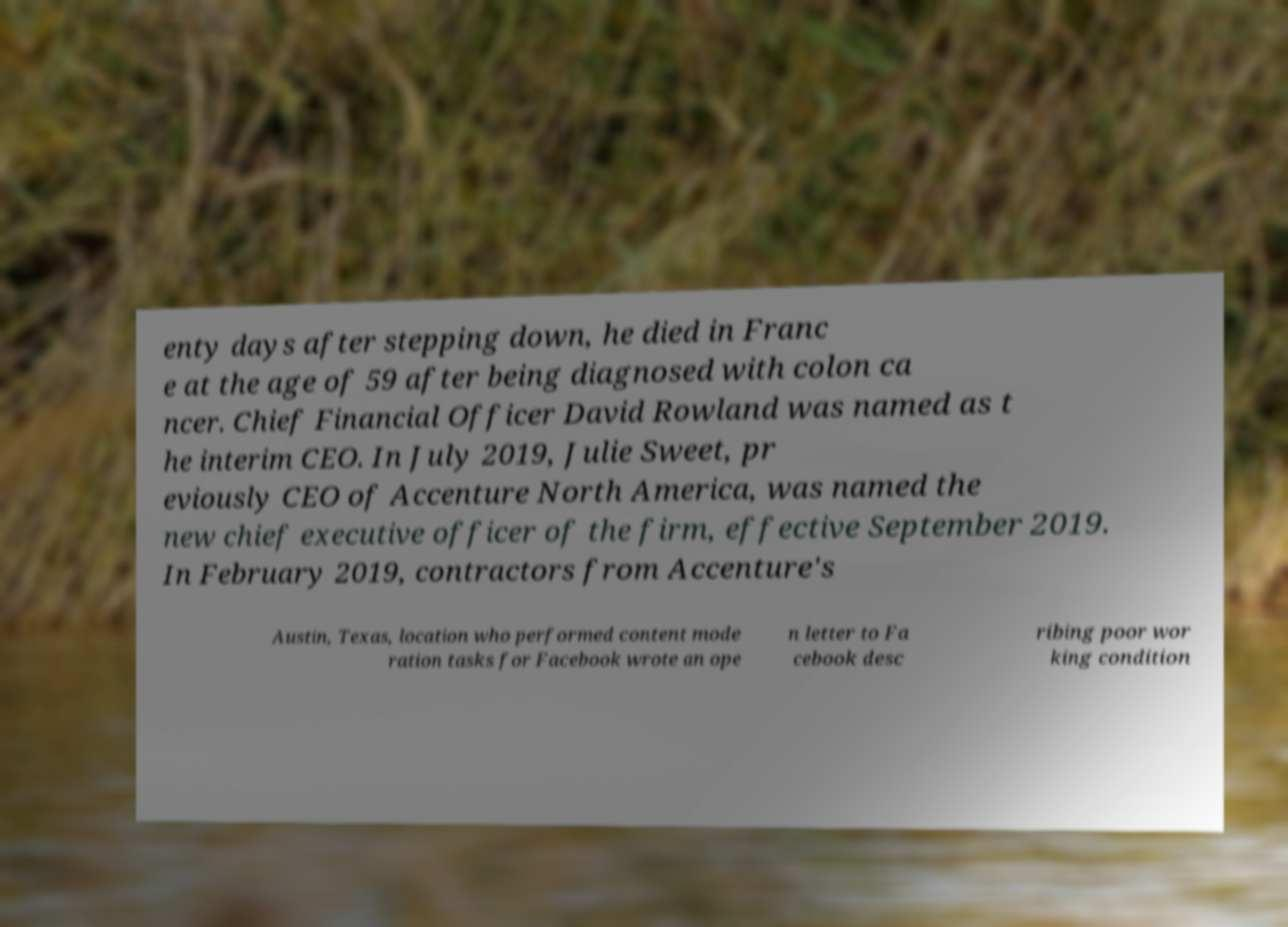Could you assist in decoding the text presented in this image and type it out clearly? enty days after stepping down, he died in Franc e at the age of 59 after being diagnosed with colon ca ncer. Chief Financial Officer David Rowland was named as t he interim CEO. In July 2019, Julie Sweet, pr eviously CEO of Accenture North America, was named the new chief executive officer of the firm, effective September 2019. In February 2019, contractors from Accenture's Austin, Texas, location who performed content mode ration tasks for Facebook wrote an ope n letter to Fa cebook desc ribing poor wor king condition 